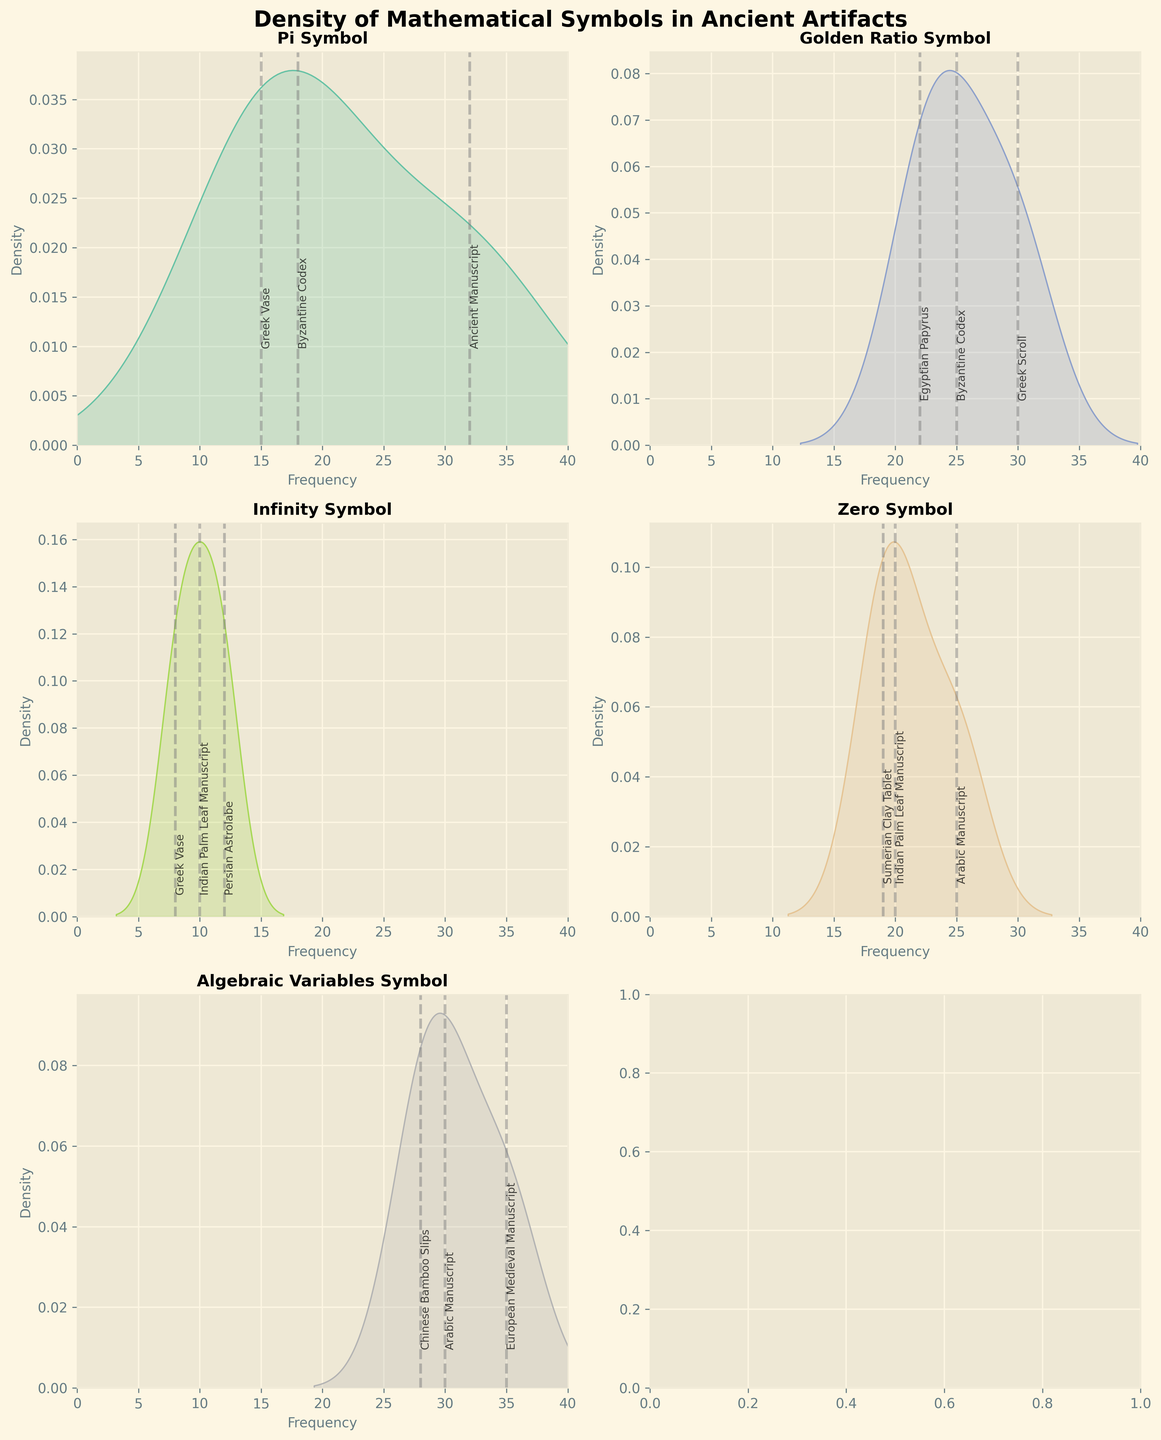What's the title of the figure? The title is displayed at the top center of the figure. It is in a bold font.
Answer: Density of Mathematical Symbols in Ancient Artifacts What are the labels for the x-axis and y-axis in the subplot for the 'Pi' symbol? In the subplot for the 'Pi' symbol, the labels for the x-axis and y-axis are shown below and to the left of the plot respectively. The x-axis label is "Frequency," and the y-axis label is "Density."
Answer: Frequency, Density Which mathematical symbol has the highest maximum frequency among the artifacts? By examining the x-axes of all subplots, we can see that "Pi" has a maximum frequency of 32, while others are lower.
Answer: Pi What artifact has the highest frequency for the 'Zero' symbol? In the subplot for the 'Zero' symbol, locate the highest vertical dashed line and refer to the label next to it. The artifact is "Arabic Manuscript," with a frequency of 25.
Answer: Arabic Manuscript Compare the density distribution depths of 'Golden Ratio' and 'Infinity' symbols. Which one has a deeper peak? View the density curves on the subplots for 'Golden Ratio' and 'Infinity.' The 'Golden Ratio' symbol’s peak covers more area under its curve, indicating it has a deeper peak.
Answer: Golden Ratio How many data points are there for the 'Algebraic Variables' symbol? By counting the artifacts listed in the 'Algebraic Variables' subplot and the corresponding vertical dashed lines, there are three data points.
Answer: 3 What's the average frequency of the 'Infinity' symbol? The frequencies for 'Infinity' are 10, 8, and 12. Calculate the sum: 10 + 8 + 12 = 30. Divide by 3 to find the average: 30 / 3 = 10.
Answer: 10 Which symbol has the narrowest frequency range? Compare the range of frequencies in all subplots by measuring the difference between minimum and maximum values. 'Infinity' has frequencies of 8, 10, and 12, giving it a range of 4, which is the narrowest.
Answer: Infinity Which symbol appears on the 'Greek Vase' artifact and what's its frequency? Scan the subplots to identify which contains 'Greek Vase.’ ‘Pi’ symbol appears on the artifact 'Greek Vase' with a frequency of 15.
Answer: Pi, 15 